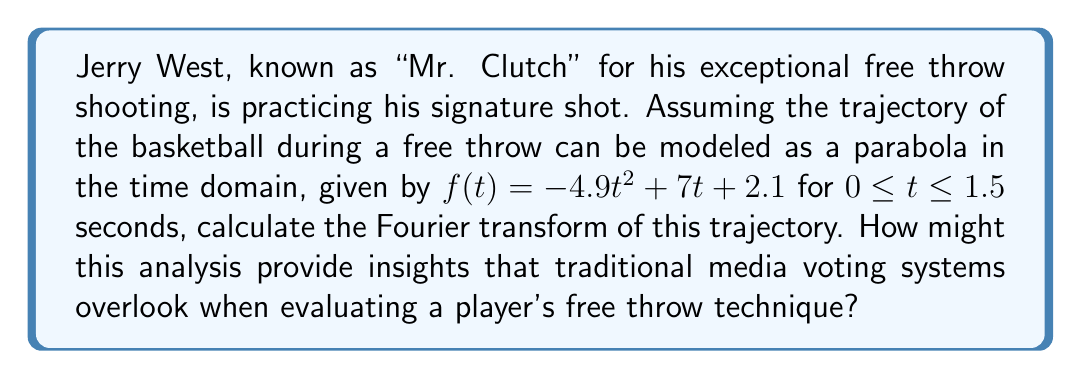Help me with this question. To solve this problem, we need to calculate the Fourier transform of the given parabolic function. Let's break it down step by step:

1) The Fourier transform of a function $f(t)$ is defined as:

   $$F(\omega) = \int_{-\infty}^{\infty} f(t) e^{-i\omega t} dt$$

2) In our case, $f(t) = -4.9t^2 + 7t + 2.1$ for $0 \leq t \leq 1.5$, and $f(t) = 0$ elsewhere.

3) Therefore, our integral becomes:

   $$F(\omega) = \int_{0}^{1.5} (-4.9t^2 + 7t + 2.1) e^{-i\omega t} dt$$

4) Let's break this into three integrals:

   $$F(\omega) = -4.9 \int_{0}^{1.5} t^2 e^{-i\omega t} dt + 7 \int_{0}^{1.5} t e^{-i\omega t} dt + 2.1 \int_{0}^{1.5} e^{-i\omega t} dt$$

5) We can solve these integrals using integration by parts and the properties of complex exponentials:

   $$\int_{0}^{1.5} t^2 e^{-i\omega t} dt = \frac{2i}{\omega^3}(3\omega - 2i + e^{-1.5i\omega}(-3\omega - 2i))$$
   
   $$\int_{0}^{1.5} t e^{-i\omega t} dt = \frac{i}{\omega^2}(1 - e^{-1.5i\omega}(\omega i + 1))$$
   
   $$\int_{0}^{1.5} e^{-i\omega t} dt = \frac{1}{i\omega}(1 - e^{-1.5i\omega})$$

6) Substituting these back into our equation:

   $$F(\omega) = -4.9 \cdot \frac{2i}{\omega^3}(3\omega - 2i + e^{-1.5i\omega}(-3\omega - 2i)) + 7 \cdot \frac{i}{\omega^2}(1 - e^{-1.5i\omega}(\omega i + 1)) + 2.1 \cdot \frac{1}{i\omega}(1 - e^{-1.5i\omega})$$

7) This can be simplified, but the exact form depends on whether we want to express it in terms of real and imaginary parts or magnitude and phase.

This analysis provides insights into the frequency components of Jerry West's free throw trajectory, which traditional media voting systems might overlook. It allows for a more precise, quantitative evaluation of the shot's smoothness and consistency, potentially revealing subtleties in technique that contribute to West's exceptional accuracy.
Answer: $$F(\omega) = -4.9 \cdot \frac{2i}{\omega^3}(3\omega - 2i + e^{-1.5i\omega}(-3\omega - 2i)) + 7 \cdot \frac{i}{\omega^2}(1 - e^{-1.5i\omega}(\omega i + 1)) + 2.1 \cdot \frac{1}{i\omega}(1 - e^{-1.5i\omega})$$ 